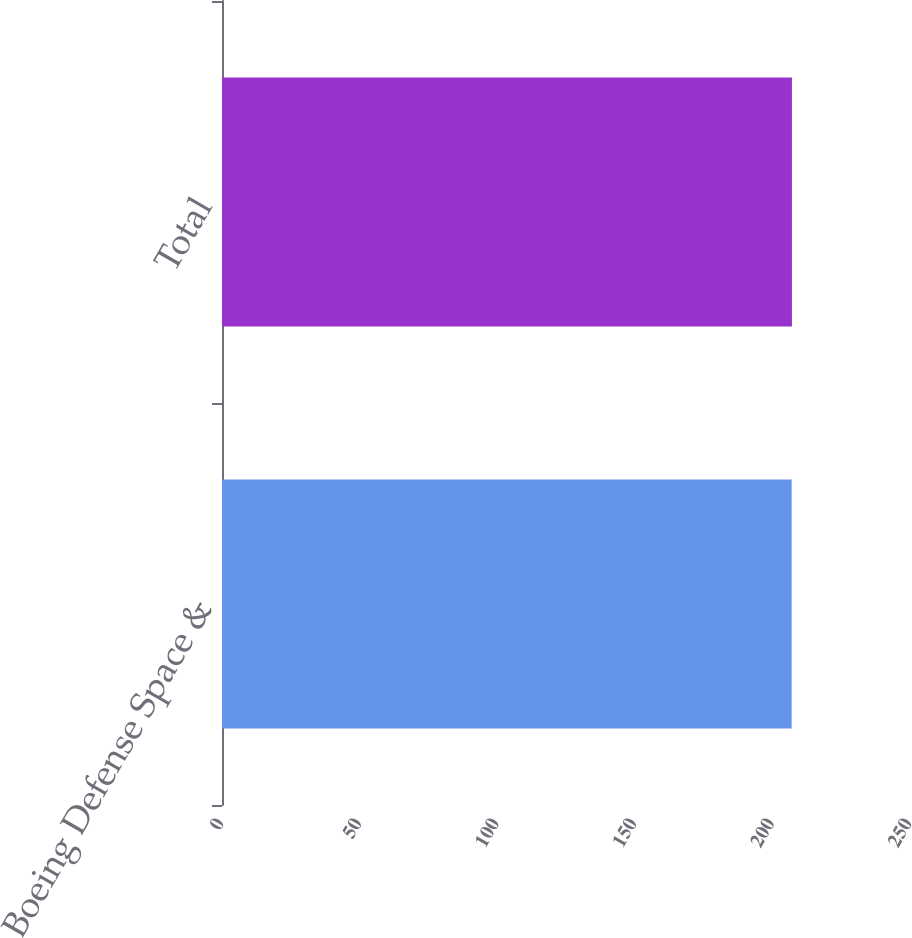<chart> <loc_0><loc_0><loc_500><loc_500><bar_chart><fcel>Boeing Defense Space &<fcel>Total<nl><fcel>207<fcel>207.1<nl></chart> 